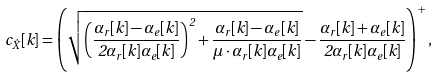Convert formula to latex. <formula><loc_0><loc_0><loc_500><loc_500>c _ { \hat { X } } [ k ] = \left ( \sqrt { \left ( \frac { \alpha _ { r } [ k ] - \alpha _ { e } [ k ] } { 2 \alpha _ { r } [ k ] \alpha _ { e } [ k ] } \right ) ^ { 2 } + \frac { \alpha _ { r } [ k ] - \alpha _ { e } [ k ] } { \mu \cdot \alpha _ { r } [ k ] \alpha _ { e } [ k ] } } - \frac { \alpha _ { r } [ k ] + \alpha _ { e } [ k ] } { 2 \alpha _ { r } [ k ] \alpha _ { e } [ k ] } \right ) ^ { + } ,</formula> 